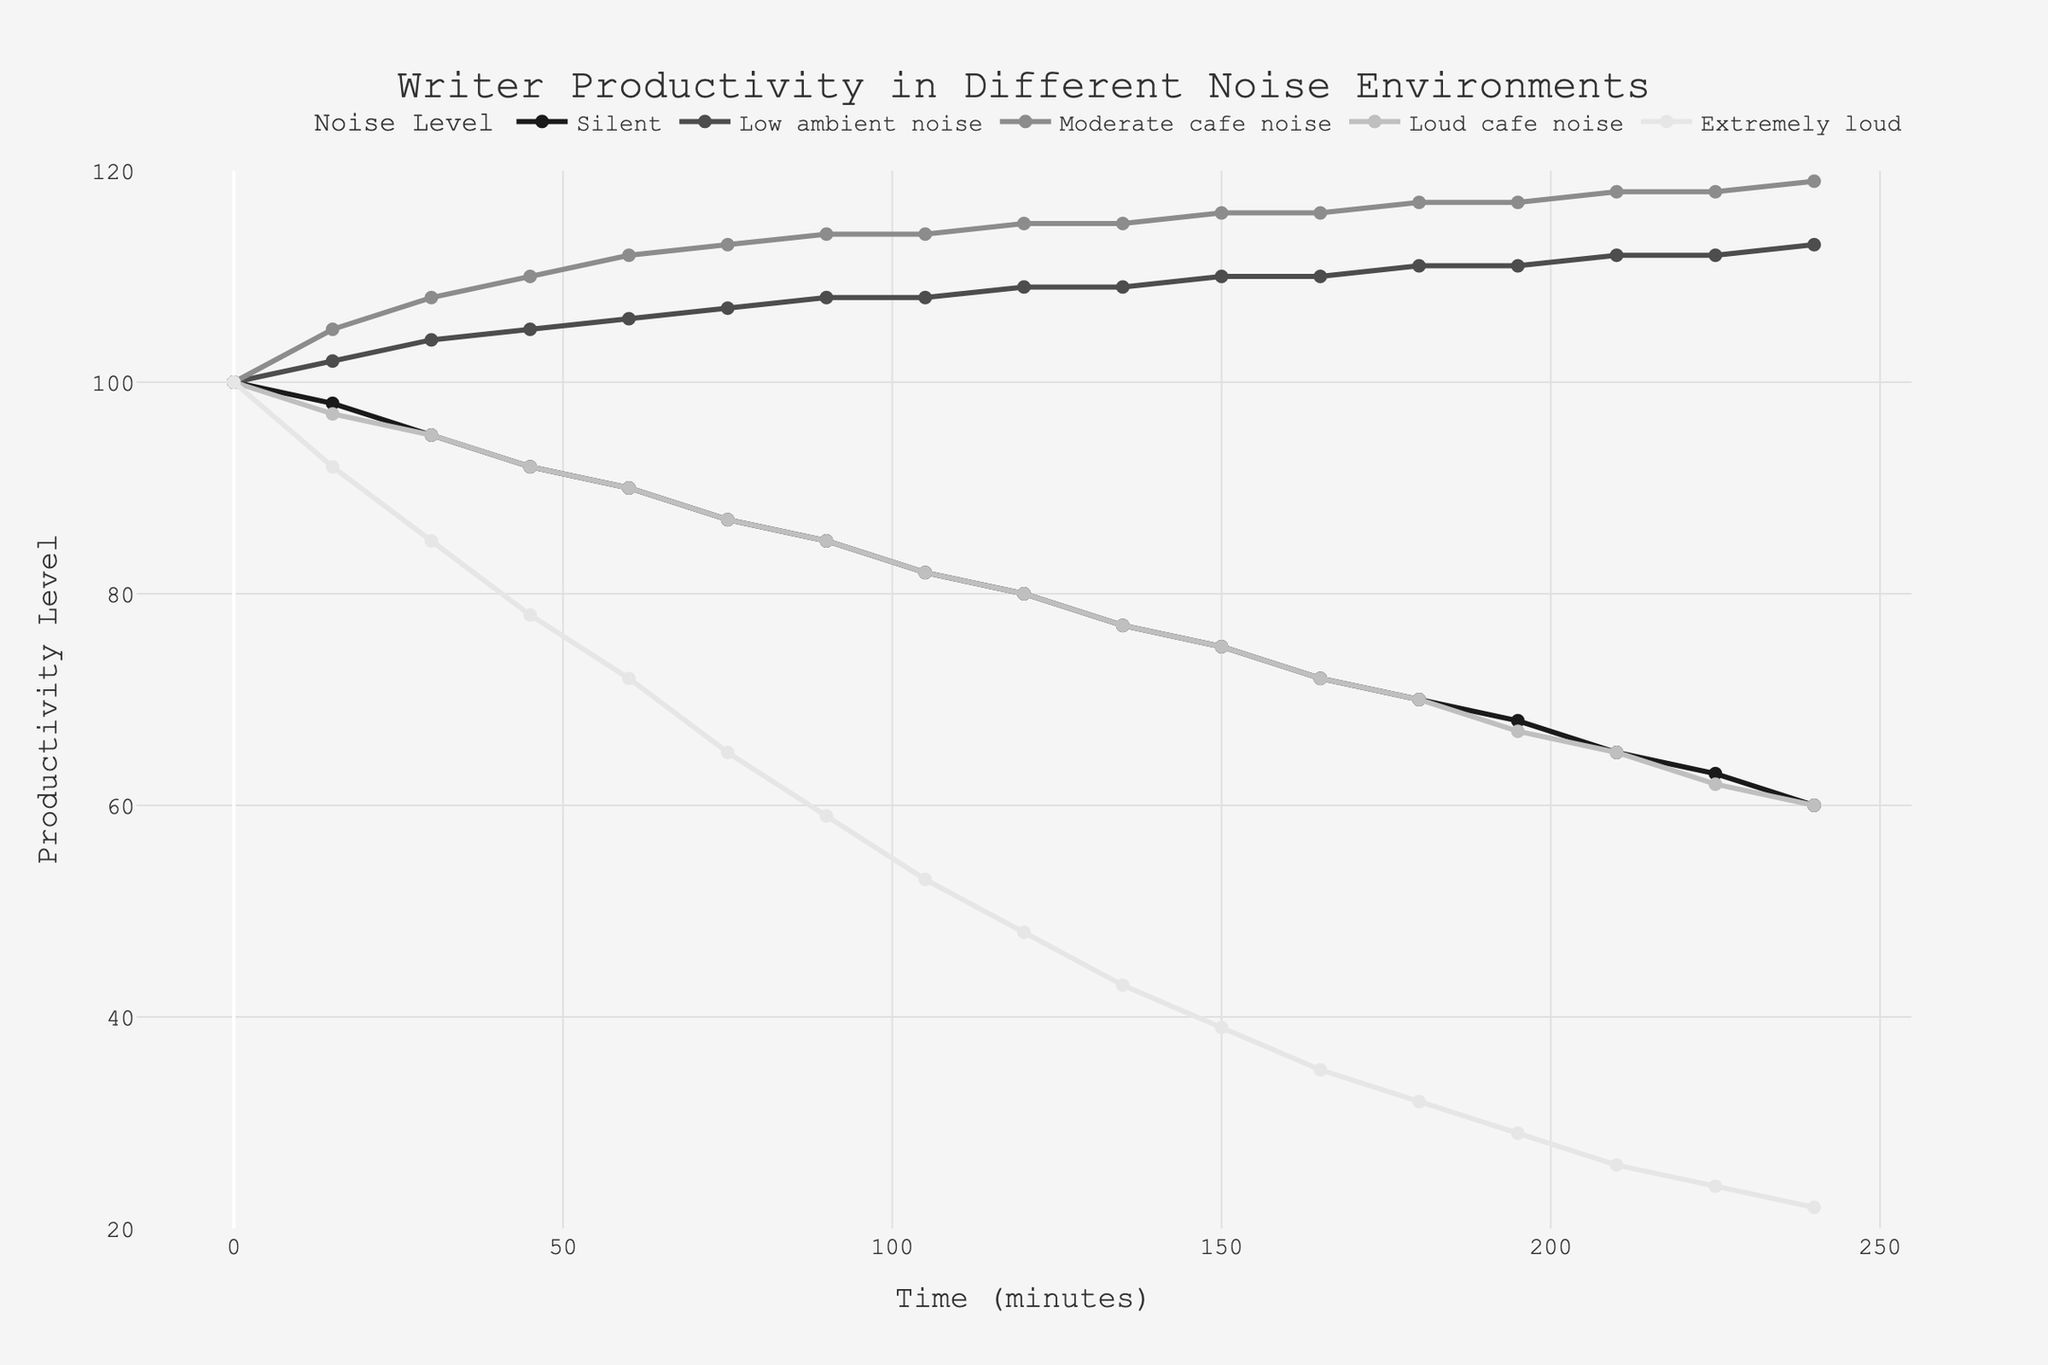Which noise environment shows the highest productivity at the 90-minute mark? Look at the 90-minute mark across all noise environments and find the highest productivity level. The highest is 114 in "Moderate cafe noise"
Answer: Moderate cafe noise How does productivity change over time in a silent environment? Observe the "Silent" line. It starts at 100 and gradually decreases, reaching 60 by the end
Answer: It decreases Which noise level maintains a relatively stable productivity level? Look for the line that fluctuates the least over time. "Low ambient noise" fluctuates very little, staying around 100-113
Answer: Low ambient noise Between which two time points does the productivity drop the fastest in extremely loud environments? Examine the "Extremely loud" line for the steepest drop. The biggest drop is between 15 and 30 minutes, where it falls from 92 to 85
Answer: Between 15 and 30 minutes What is the difference in productivity at the 120-minute mark between "Loud cafe noise" and "Extremely loud"? At the 120-minute mark, "Loud cafe noise" is 80, and "Extremely loud" is 48. Subtract the latter from the former: 80 - 48 = 32
Answer: 32 What trend do we observe in productivity in "Moderate cafe noise" over 240 minutes? Trace the "Moderate cafe noise" line; it starts at 100, steadily increases, and peaks at 119
Answer: It increases Which noise environment shows the fastest initial increase in productivity levels in the first 45 minutes? Compare the increase from 0 to 45 minutes across all noise levels. "Moderate cafe noise" increases from 100 to 110, the highest increase
Answer: Moderate cafe noise How do the productivity levels at the start compare between the noise environments? All lines start at the same point, 100, indicating that initial productivity is the same across all environments
Answer: They are the same What is the average productivity level across all environments at the 180-minute mark? Sum the productivity levels at 180 minutes for all noise environments: 70 (Silent) + 111 (Low ambient noise) + 117 (Moderate cafe noise) + 70 (Loud cafe noise) + 32 (Extremely loud). The total is 400. Divide by 5: 400 / 5 = 80
Answer: 80 